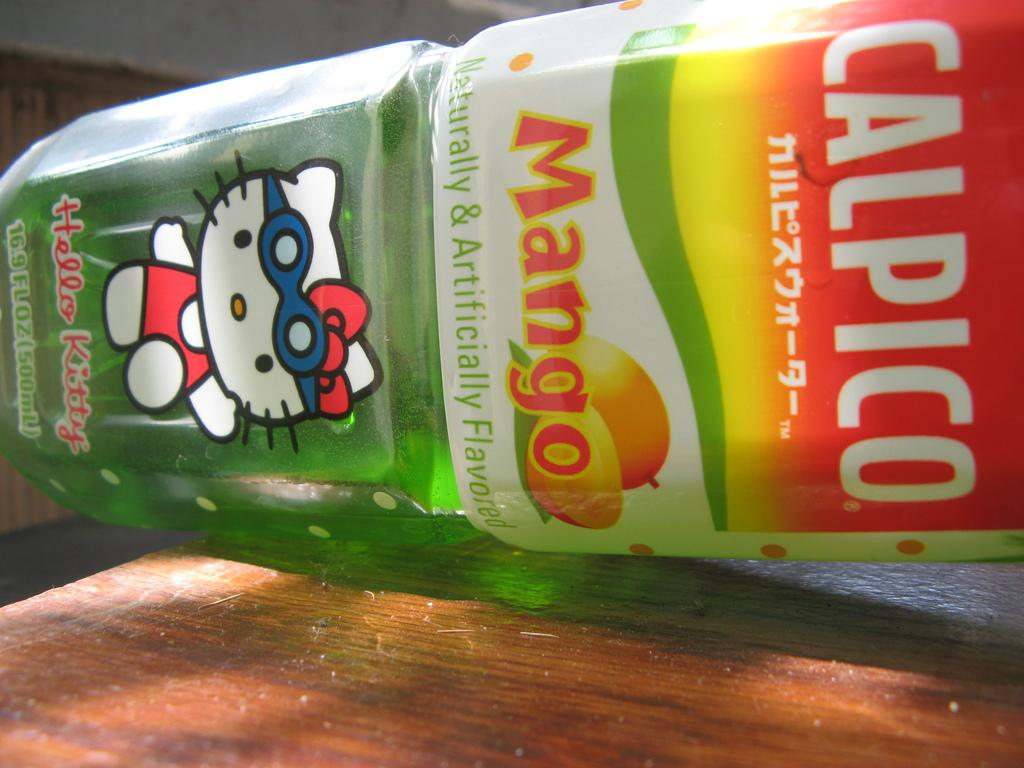Provide a one-sentence caption for the provided image. A bottle of Mango Calpico with a Hello Kitty picture on the bottom. 